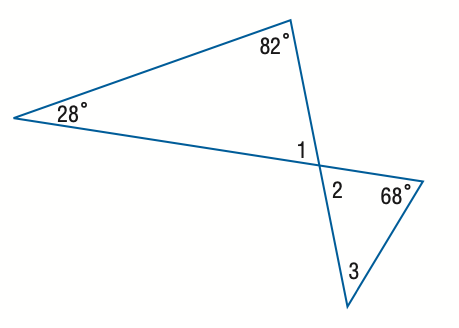Question: Find the measure of \angle 1.
Choices:
A. 68
B. 70
C. 70
D. 82
Answer with the letter. Answer: B Question: Find the measure of \angle 3.
Choices:
A. 28
B. 32
C. 38
D. 42
Answer with the letter. Answer: D 